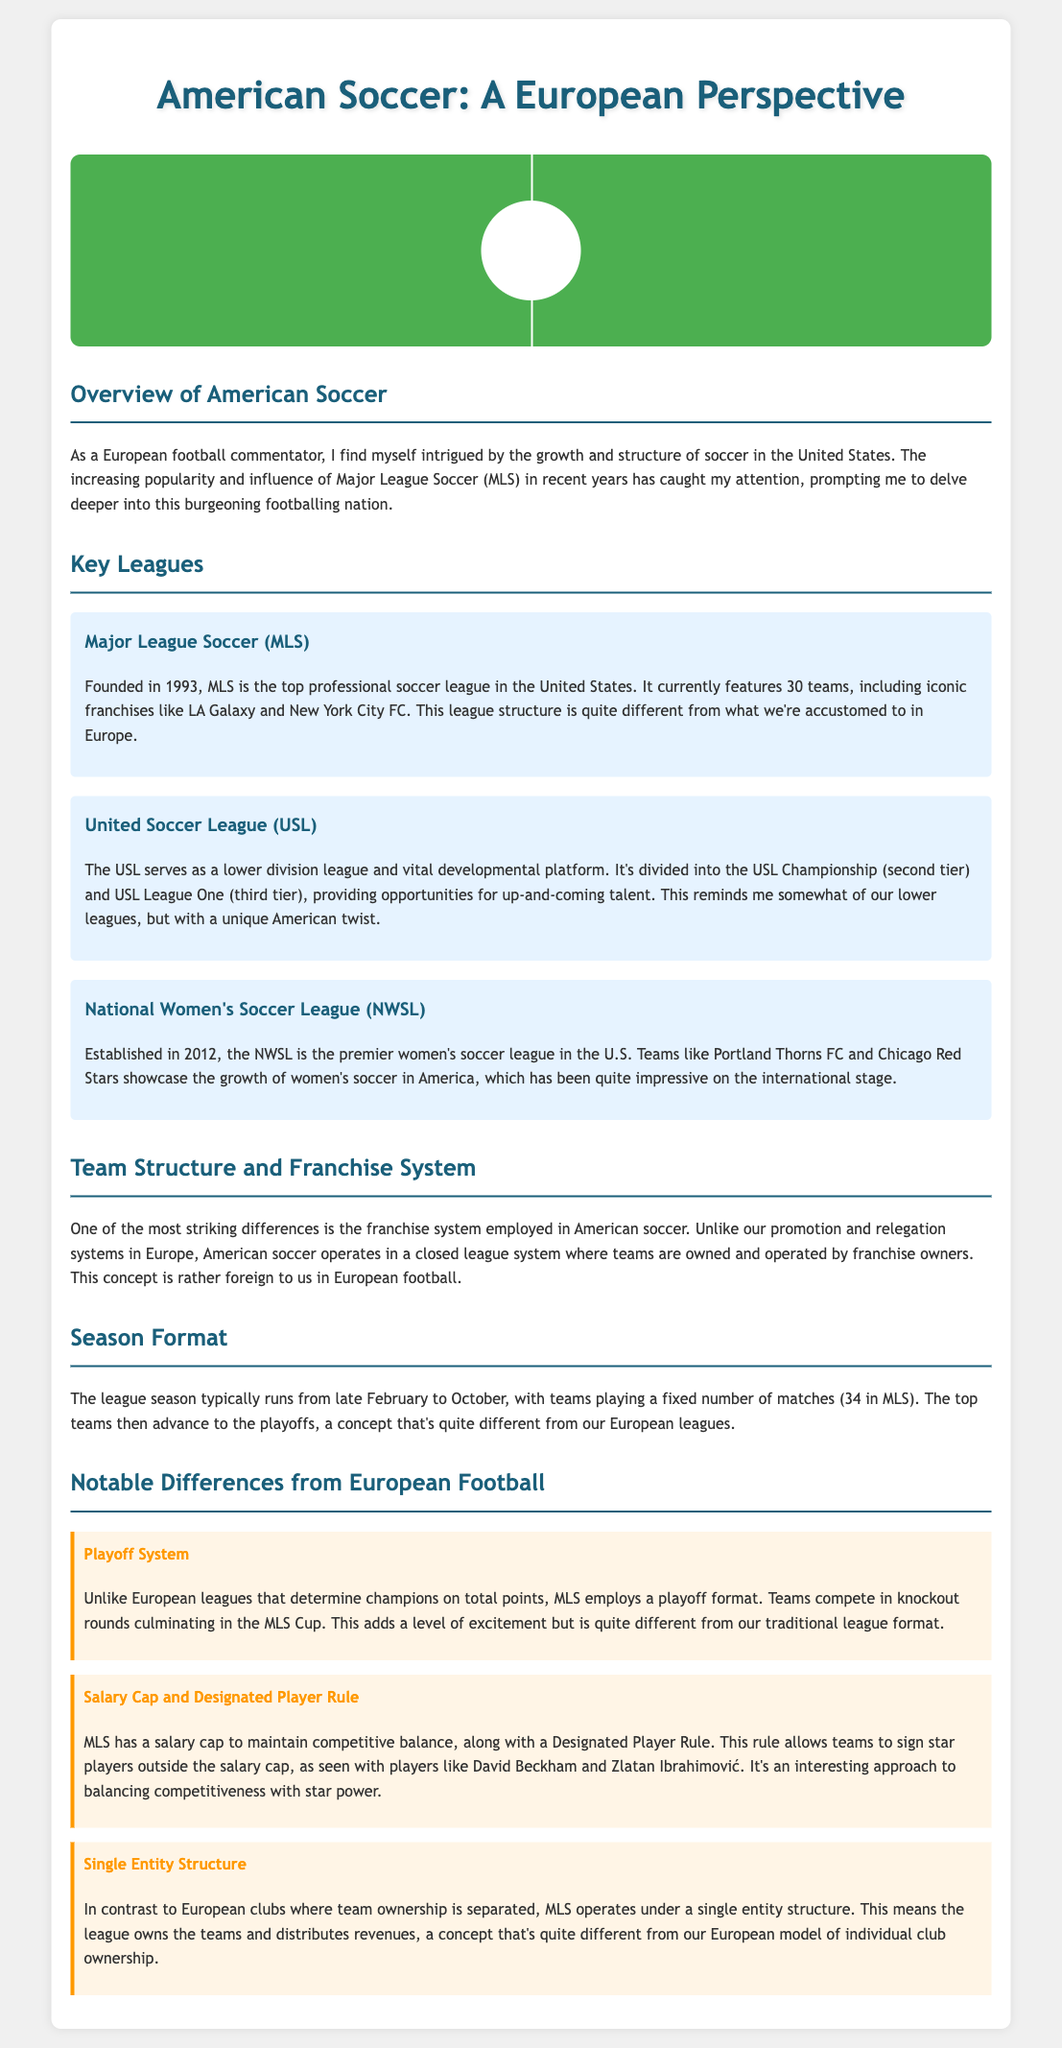What is the top professional soccer league in the United States? The document specifies that Major League Soccer (MLS) is the top professional soccer league in the United States.
Answer: Major League Soccer (MLS) How many teams are currently in MLS? According to the document, MLS currently features 30 teams.
Answer: 30 What year was Major League Soccer founded? The document states that MLS was founded in 1993.
Answer: 1993 What is the primary women's soccer league in the U.S.? The document identifies the National Women's Soccer League (NWSL) as the premier women's soccer league in the U.S.
Answer: National Women's Soccer League (NWSL) What concept in American soccer differs from European promotion and relegation? The document notes that American soccer operates with a closed league system rather than the promotion and relegation system seen in Europe.
Answer: Closed league system What is the season format for MLS? The document describes that the MLS season typically runs from late February to October with 34 matches.
Answer: Late February to October, 34 matches What playoff format is used in MLS? The document explains that MLS employs a playoff format culminating in the MLS Cup, which is quite different from total points in European leagues.
Answer: Playoff format What is the Designated Player Rule in MLS? The document mentions that the Designated Player Rule allows teams to sign star players outside the salary cap.
Answer: Allows signing star players outside salary cap How is team ownership structured in MLS? The document explains that MLS operates under a single entity structure, meaning the league owns the teams.
Answer: Single entity structure 